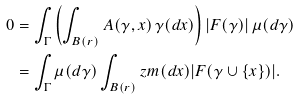<formula> <loc_0><loc_0><loc_500><loc_500>0 & = \int _ { \Gamma } \left ( \int _ { B ( r ) } A ( \gamma , x ) \, \gamma ( d x ) \right ) | F ( \gamma ) | \, \mu ( d \gamma ) \\ & = \int _ { \Gamma } \mu ( d \gamma ) \int _ { B ( r ) } z m ( d x ) | F ( \gamma \cup \{ x \} ) | .</formula> 